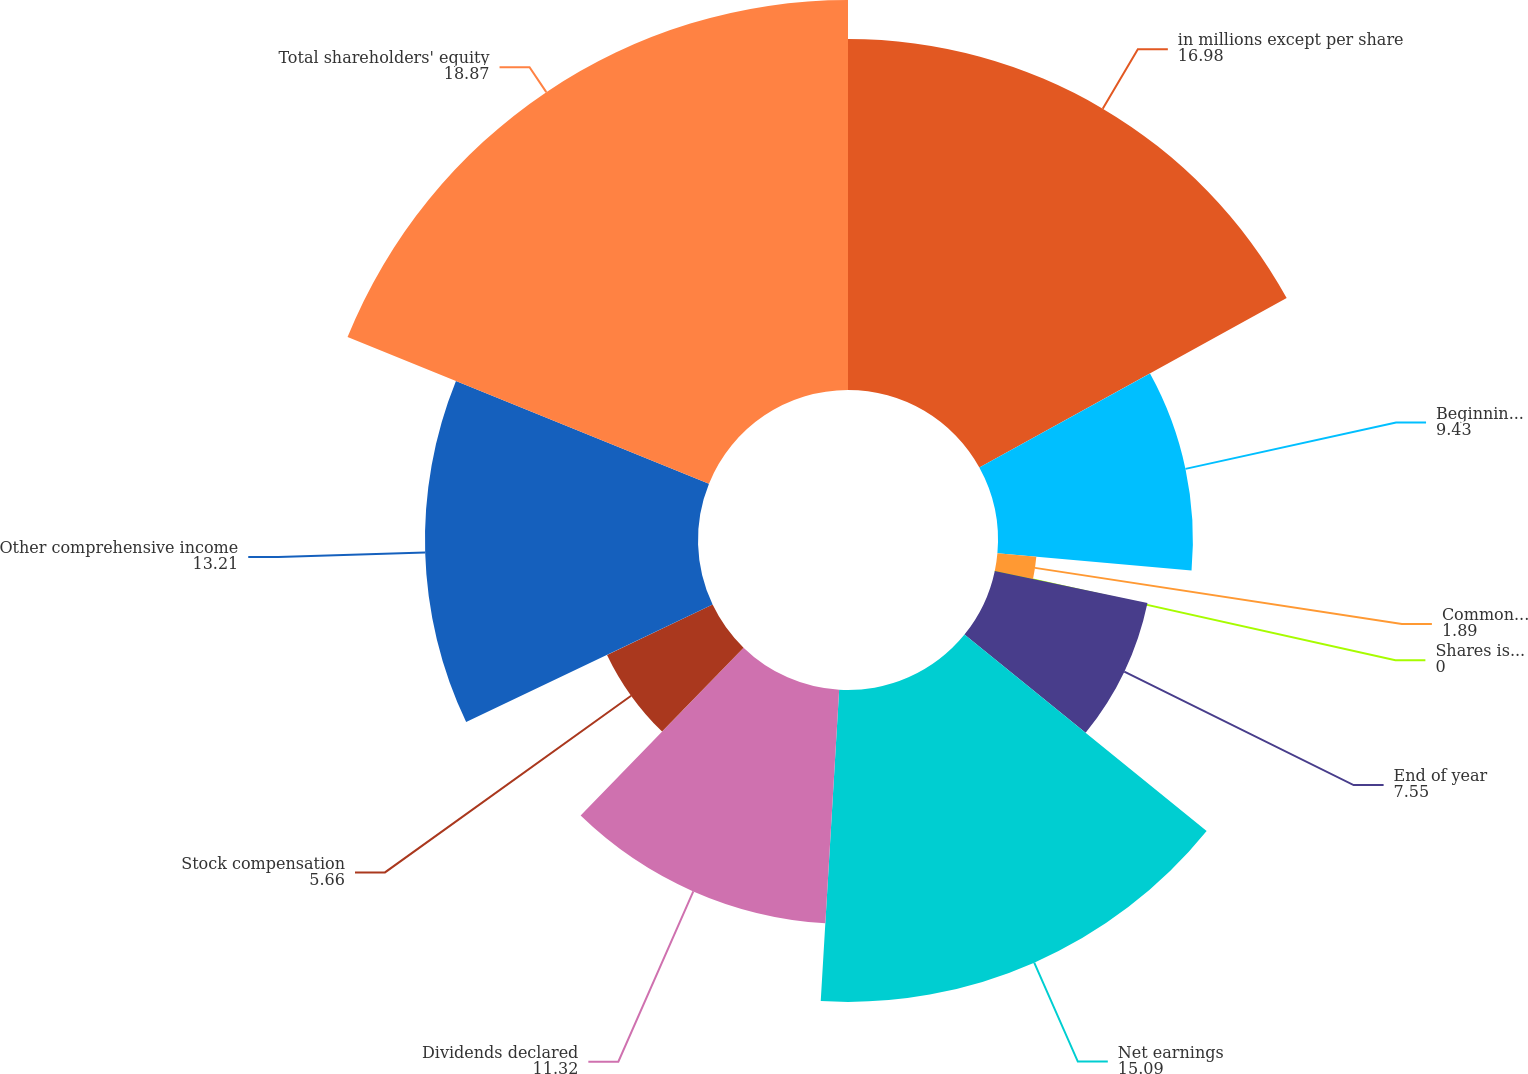<chart> <loc_0><loc_0><loc_500><loc_500><pie_chart><fcel>in millions except per share<fcel>Beginning of year<fcel>Common stock repurchased<fcel>Shares issued for employee<fcel>End of year<fcel>Net earnings<fcel>Dividends declared<fcel>Stock compensation<fcel>Other comprehensive income<fcel>Total shareholders' equity<nl><fcel>16.98%<fcel>9.43%<fcel>1.89%<fcel>0.0%<fcel>7.55%<fcel>15.09%<fcel>11.32%<fcel>5.66%<fcel>13.21%<fcel>18.87%<nl></chart> 